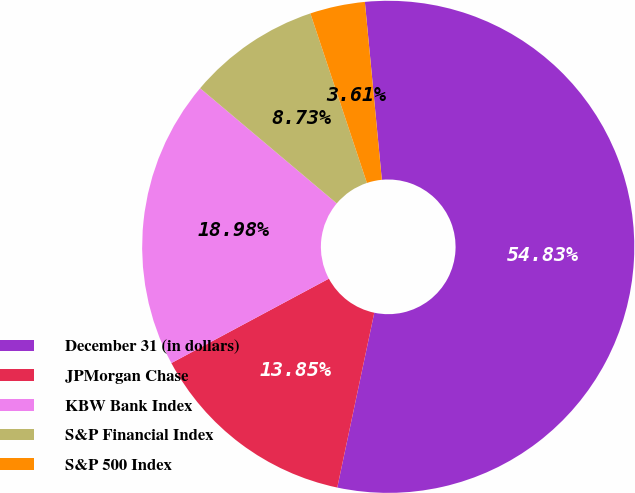<chart> <loc_0><loc_0><loc_500><loc_500><pie_chart><fcel>December 31 (in dollars)<fcel>JPMorgan Chase<fcel>KBW Bank Index<fcel>S&P Financial Index<fcel>S&P 500 Index<nl><fcel>54.84%<fcel>13.85%<fcel>18.98%<fcel>8.73%<fcel>3.61%<nl></chart> 